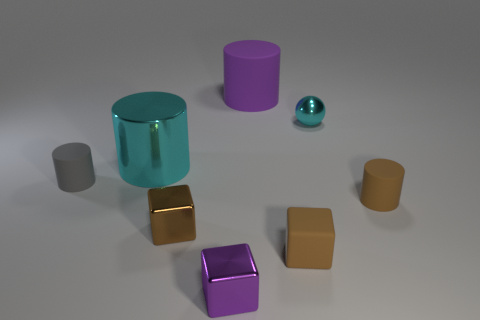Can you describe the different textures and colors visible in this image? Certainly! There are a variety of textures on display: a shiny, reflective cyan cylinder, a grainy matte gold block, and multiple matte objects in shades of purple, gray, and beige. The colors range from vibrant and eye-catching to understated and muted, creating a diverse visual palette. 